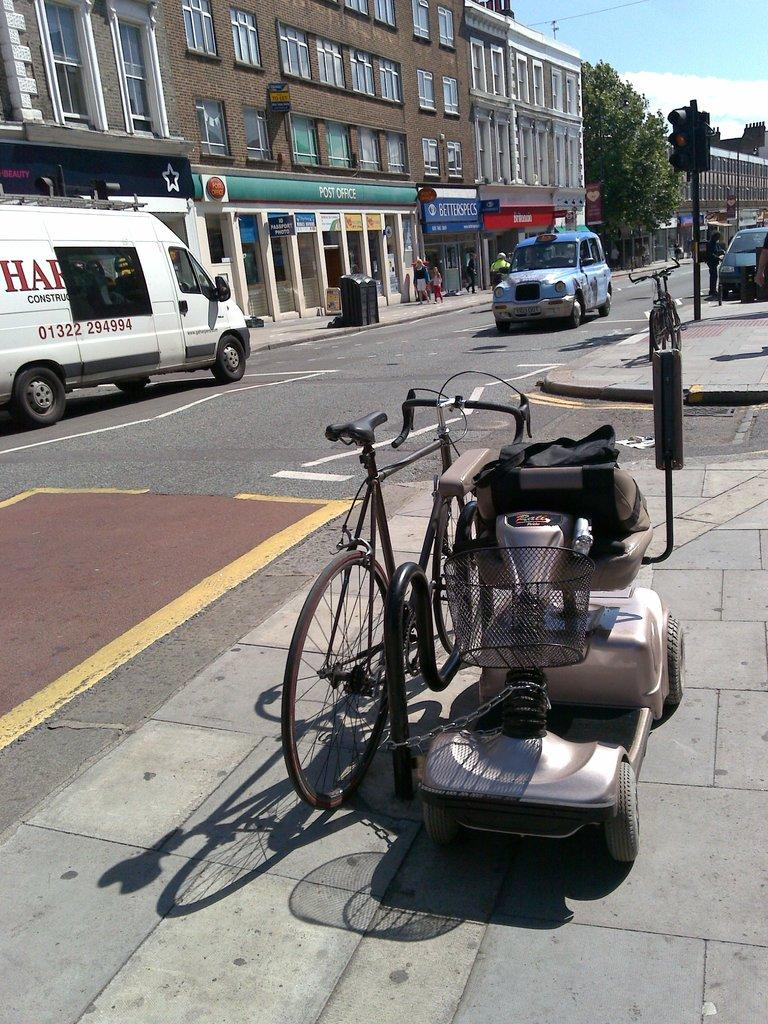<image>
Present a compact description of the photo's key features. A blue car is going down a street past a green sign that says Post Office. 